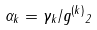<formula> <loc_0><loc_0><loc_500><loc_500>\alpha _ { k } = \gamma _ { k } / \| g ^ { ( k ) } \| _ { 2 }</formula> 